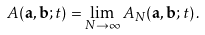Convert formula to latex. <formula><loc_0><loc_0><loc_500><loc_500>A ( \mathbf a , \mathbf b ; t ) = \lim _ { N \to \infty } A _ { N } ( \mathbf a , \mathbf b ; t ) \, .</formula> 